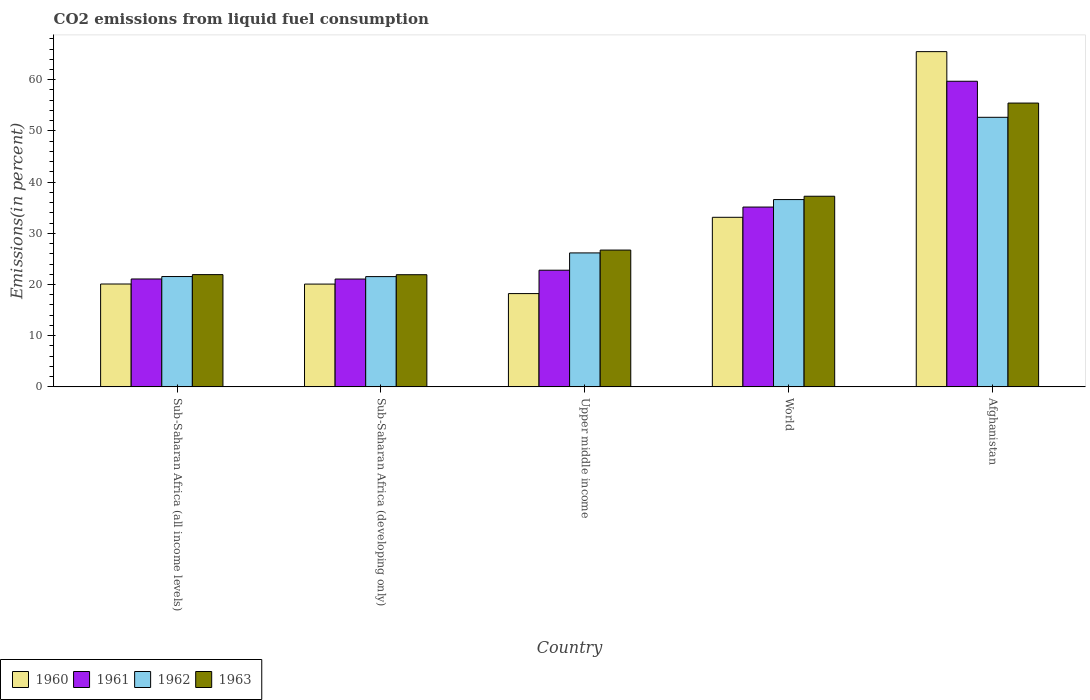How many bars are there on the 1st tick from the left?
Your answer should be very brief. 4. How many bars are there on the 4th tick from the right?
Provide a succinct answer. 4. What is the label of the 1st group of bars from the left?
Provide a succinct answer. Sub-Saharan Africa (all income levels). What is the total CO2 emitted in 1960 in Afghanistan?
Provide a succinct answer. 65.49. Across all countries, what is the maximum total CO2 emitted in 1963?
Your answer should be very brief. 55.44. Across all countries, what is the minimum total CO2 emitted in 1962?
Give a very brief answer. 21.54. In which country was the total CO2 emitted in 1963 maximum?
Your response must be concise. Afghanistan. In which country was the total CO2 emitted in 1961 minimum?
Your answer should be compact. Sub-Saharan Africa (developing only). What is the total total CO2 emitted in 1962 in the graph?
Provide a short and direct response. 158.51. What is the difference between the total CO2 emitted in 1960 in Upper middle income and that in World?
Your answer should be very brief. -14.9. What is the difference between the total CO2 emitted in 1961 in Upper middle income and the total CO2 emitted in 1963 in Afghanistan?
Your answer should be compact. -32.65. What is the average total CO2 emitted in 1961 per country?
Ensure brevity in your answer.  31.95. What is the difference between the total CO2 emitted of/in 1960 and total CO2 emitted of/in 1963 in Sub-Saharan Africa (all income levels)?
Offer a terse response. -1.83. In how many countries, is the total CO2 emitted in 1960 greater than 22 %?
Give a very brief answer. 2. What is the ratio of the total CO2 emitted in 1962 in Sub-Saharan Africa (all income levels) to that in Sub-Saharan Africa (developing only)?
Provide a short and direct response. 1. Is the difference between the total CO2 emitted in 1960 in Sub-Saharan Africa (all income levels) and Upper middle income greater than the difference between the total CO2 emitted in 1963 in Sub-Saharan Africa (all income levels) and Upper middle income?
Provide a short and direct response. Yes. What is the difference between the highest and the second highest total CO2 emitted in 1963?
Your answer should be compact. -10.51. What is the difference between the highest and the lowest total CO2 emitted in 1960?
Offer a very short reply. 47.26. What does the 1st bar from the left in Sub-Saharan Africa (developing only) represents?
Make the answer very short. 1960. Is it the case that in every country, the sum of the total CO2 emitted in 1962 and total CO2 emitted in 1960 is greater than the total CO2 emitted in 1963?
Keep it short and to the point. Yes. Are all the bars in the graph horizontal?
Give a very brief answer. No. How many countries are there in the graph?
Offer a terse response. 5. Are the values on the major ticks of Y-axis written in scientific E-notation?
Ensure brevity in your answer.  No. Does the graph contain any zero values?
Provide a succinct answer. No. How many legend labels are there?
Give a very brief answer. 4. How are the legend labels stacked?
Make the answer very short. Horizontal. What is the title of the graph?
Your answer should be very brief. CO2 emissions from liquid fuel consumption. What is the label or title of the Y-axis?
Make the answer very short. Emissions(in percent). What is the Emissions(in percent) of 1960 in Sub-Saharan Africa (all income levels)?
Keep it short and to the point. 20.09. What is the Emissions(in percent) of 1961 in Sub-Saharan Africa (all income levels)?
Your response must be concise. 21.08. What is the Emissions(in percent) in 1962 in Sub-Saharan Africa (all income levels)?
Provide a short and direct response. 21.55. What is the Emissions(in percent) of 1963 in Sub-Saharan Africa (all income levels)?
Keep it short and to the point. 21.93. What is the Emissions(in percent) in 1960 in Sub-Saharan Africa (developing only)?
Provide a short and direct response. 20.08. What is the Emissions(in percent) of 1961 in Sub-Saharan Africa (developing only)?
Offer a terse response. 21.06. What is the Emissions(in percent) in 1962 in Sub-Saharan Africa (developing only)?
Give a very brief answer. 21.54. What is the Emissions(in percent) of 1963 in Sub-Saharan Africa (developing only)?
Provide a succinct answer. 21.91. What is the Emissions(in percent) of 1960 in Upper middle income?
Keep it short and to the point. 18.22. What is the Emissions(in percent) in 1961 in Upper middle income?
Provide a succinct answer. 22.79. What is the Emissions(in percent) of 1962 in Upper middle income?
Offer a terse response. 26.17. What is the Emissions(in percent) of 1963 in Upper middle income?
Provide a succinct answer. 26.72. What is the Emissions(in percent) in 1960 in World?
Keep it short and to the point. 33.13. What is the Emissions(in percent) of 1961 in World?
Provide a succinct answer. 35.13. What is the Emissions(in percent) of 1962 in World?
Your answer should be compact. 36.59. What is the Emissions(in percent) of 1963 in World?
Your answer should be very brief. 37.24. What is the Emissions(in percent) in 1960 in Afghanistan?
Offer a very short reply. 65.49. What is the Emissions(in percent) of 1961 in Afghanistan?
Your answer should be compact. 59.7. What is the Emissions(in percent) in 1962 in Afghanistan?
Your response must be concise. 52.66. What is the Emissions(in percent) in 1963 in Afghanistan?
Keep it short and to the point. 55.44. Across all countries, what is the maximum Emissions(in percent) in 1960?
Offer a very short reply. 65.49. Across all countries, what is the maximum Emissions(in percent) in 1961?
Give a very brief answer. 59.7. Across all countries, what is the maximum Emissions(in percent) of 1962?
Provide a short and direct response. 52.66. Across all countries, what is the maximum Emissions(in percent) in 1963?
Offer a terse response. 55.44. Across all countries, what is the minimum Emissions(in percent) in 1960?
Provide a succinct answer. 18.22. Across all countries, what is the minimum Emissions(in percent) of 1961?
Your answer should be compact. 21.06. Across all countries, what is the minimum Emissions(in percent) of 1962?
Your answer should be very brief. 21.54. Across all countries, what is the minimum Emissions(in percent) in 1963?
Your answer should be very brief. 21.91. What is the total Emissions(in percent) of 1960 in the graph?
Your response must be concise. 157.01. What is the total Emissions(in percent) in 1961 in the graph?
Make the answer very short. 159.76. What is the total Emissions(in percent) of 1962 in the graph?
Offer a very short reply. 158.51. What is the total Emissions(in percent) in 1963 in the graph?
Your answer should be very brief. 163.24. What is the difference between the Emissions(in percent) of 1960 in Sub-Saharan Africa (all income levels) and that in Sub-Saharan Africa (developing only)?
Your response must be concise. 0.01. What is the difference between the Emissions(in percent) in 1961 in Sub-Saharan Africa (all income levels) and that in Sub-Saharan Africa (developing only)?
Give a very brief answer. 0.01. What is the difference between the Emissions(in percent) in 1962 in Sub-Saharan Africa (all income levels) and that in Sub-Saharan Africa (developing only)?
Offer a terse response. 0.01. What is the difference between the Emissions(in percent) in 1963 in Sub-Saharan Africa (all income levels) and that in Sub-Saharan Africa (developing only)?
Your answer should be compact. 0.02. What is the difference between the Emissions(in percent) in 1960 in Sub-Saharan Africa (all income levels) and that in Upper middle income?
Your response must be concise. 1.87. What is the difference between the Emissions(in percent) in 1961 in Sub-Saharan Africa (all income levels) and that in Upper middle income?
Keep it short and to the point. -1.71. What is the difference between the Emissions(in percent) in 1962 in Sub-Saharan Africa (all income levels) and that in Upper middle income?
Your response must be concise. -4.61. What is the difference between the Emissions(in percent) in 1963 in Sub-Saharan Africa (all income levels) and that in Upper middle income?
Offer a terse response. -4.8. What is the difference between the Emissions(in percent) of 1960 in Sub-Saharan Africa (all income levels) and that in World?
Offer a very short reply. -13.03. What is the difference between the Emissions(in percent) in 1961 in Sub-Saharan Africa (all income levels) and that in World?
Offer a terse response. -14.05. What is the difference between the Emissions(in percent) in 1962 in Sub-Saharan Africa (all income levels) and that in World?
Make the answer very short. -15.03. What is the difference between the Emissions(in percent) in 1963 in Sub-Saharan Africa (all income levels) and that in World?
Keep it short and to the point. -15.31. What is the difference between the Emissions(in percent) in 1960 in Sub-Saharan Africa (all income levels) and that in Afghanistan?
Your response must be concise. -45.39. What is the difference between the Emissions(in percent) of 1961 in Sub-Saharan Africa (all income levels) and that in Afghanistan?
Your answer should be very brief. -38.62. What is the difference between the Emissions(in percent) in 1962 in Sub-Saharan Africa (all income levels) and that in Afghanistan?
Provide a short and direct response. -31.11. What is the difference between the Emissions(in percent) in 1963 in Sub-Saharan Africa (all income levels) and that in Afghanistan?
Your answer should be very brief. -33.51. What is the difference between the Emissions(in percent) in 1960 in Sub-Saharan Africa (developing only) and that in Upper middle income?
Keep it short and to the point. 1.86. What is the difference between the Emissions(in percent) of 1961 in Sub-Saharan Africa (developing only) and that in Upper middle income?
Ensure brevity in your answer.  -1.73. What is the difference between the Emissions(in percent) of 1962 in Sub-Saharan Africa (developing only) and that in Upper middle income?
Offer a very short reply. -4.63. What is the difference between the Emissions(in percent) in 1963 in Sub-Saharan Africa (developing only) and that in Upper middle income?
Ensure brevity in your answer.  -4.82. What is the difference between the Emissions(in percent) of 1960 in Sub-Saharan Africa (developing only) and that in World?
Keep it short and to the point. -13.05. What is the difference between the Emissions(in percent) in 1961 in Sub-Saharan Africa (developing only) and that in World?
Your response must be concise. -14.06. What is the difference between the Emissions(in percent) in 1962 in Sub-Saharan Africa (developing only) and that in World?
Your answer should be compact. -15.05. What is the difference between the Emissions(in percent) of 1963 in Sub-Saharan Africa (developing only) and that in World?
Provide a short and direct response. -15.33. What is the difference between the Emissions(in percent) of 1960 in Sub-Saharan Africa (developing only) and that in Afghanistan?
Offer a terse response. -45.41. What is the difference between the Emissions(in percent) of 1961 in Sub-Saharan Africa (developing only) and that in Afghanistan?
Keep it short and to the point. -38.64. What is the difference between the Emissions(in percent) in 1962 in Sub-Saharan Africa (developing only) and that in Afghanistan?
Your answer should be compact. -31.12. What is the difference between the Emissions(in percent) of 1963 in Sub-Saharan Africa (developing only) and that in Afghanistan?
Provide a short and direct response. -33.53. What is the difference between the Emissions(in percent) of 1960 in Upper middle income and that in World?
Make the answer very short. -14.9. What is the difference between the Emissions(in percent) of 1961 in Upper middle income and that in World?
Your answer should be very brief. -12.34. What is the difference between the Emissions(in percent) in 1962 in Upper middle income and that in World?
Your answer should be very brief. -10.42. What is the difference between the Emissions(in percent) of 1963 in Upper middle income and that in World?
Give a very brief answer. -10.51. What is the difference between the Emissions(in percent) in 1960 in Upper middle income and that in Afghanistan?
Offer a very short reply. -47.26. What is the difference between the Emissions(in percent) in 1961 in Upper middle income and that in Afghanistan?
Keep it short and to the point. -36.91. What is the difference between the Emissions(in percent) of 1962 in Upper middle income and that in Afghanistan?
Your answer should be very brief. -26.49. What is the difference between the Emissions(in percent) of 1963 in Upper middle income and that in Afghanistan?
Provide a succinct answer. -28.72. What is the difference between the Emissions(in percent) in 1960 in World and that in Afghanistan?
Offer a terse response. -32.36. What is the difference between the Emissions(in percent) of 1961 in World and that in Afghanistan?
Your response must be concise. -24.57. What is the difference between the Emissions(in percent) in 1962 in World and that in Afghanistan?
Ensure brevity in your answer.  -16.07. What is the difference between the Emissions(in percent) of 1963 in World and that in Afghanistan?
Your answer should be compact. -18.2. What is the difference between the Emissions(in percent) in 1960 in Sub-Saharan Africa (all income levels) and the Emissions(in percent) in 1961 in Sub-Saharan Africa (developing only)?
Keep it short and to the point. -0.97. What is the difference between the Emissions(in percent) of 1960 in Sub-Saharan Africa (all income levels) and the Emissions(in percent) of 1962 in Sub-Saharan Africa (developing only)?
Keep it short and to the point. -1.45. What is the difference between the Emissions(in percent) in 1960 in Sub-Saharan Africa (all income levels) and the Emissions(in percent) in 1963 in Sub-Saharan Africa (developing only)?
Keep it short and to the point. -1.81. What is the difference between the Emissions(in percent) in 1961 in Sub-Saharan Africa (all income levels) and the Emissions(in percent) in 1962 in Sub-Saharan Africa (developing only)?
Give a very brief answer. -0.46. What is the difference between the Emissions(in percent) in 1961 in Sub-Saharan Africa (all income levels) and the Emissions(in percent) in 1963 in Sub-Saharan Africa (developing only)?
Keep it short and to the point. -0.83. What is the difference between the Emissions(in percent) of 1962 in Sub-Saharan Africa (all income levels) and the Emissions(in percent) of 1963 in Sub-Saharan Africa (developing only)?
Your answer should be compact. -0.35. What is the difference between the Emissions(in percent) in 1960 in Sub-Saharan Africa (all income levels) and the Emissions(in percent) in 1961 in Upper middle income?
Your answer should be very brief. -2.69. What is the difference between the Emissions(in percent) of 1960 in Sub-Saharan Africa (all income levels) and the Emissions(in percent) of 1962 in Upper middle income?
Provide a succinct answer. -6.07. What is the difference between the Emissions(in percent) in 1960 in Sub-Saharan Africa (all income levels) and the Emissions(in percent) in 1963 in Upper middle income?
Give a very brief answer. -6.63. What is the difference between the Emissions(in percent) of 1961 in Sub-Saharan Africa (all income levels) and the Emissions(in percent) of 1962 in Upper middle income?
Offer a very short reply. -5.09. What is the difference between the Emissions(in percent) of 1961 in Sub-Saharan Africa (all income levels) and the Emissions(in percent) of 1963 in Upper middle income?
Offer a very short reply. -5.65. What is the difference between the Emissions(in percent) of 1962 in Sub-Saharan Africa (all income levels) and the Emissions(in percent) of 1963 in Upper middle income?
Ensure brevity in your answer.  -5.17. What is the difference between the Emissions(in percent) in 1960 in Sub-Saharan Africa (all income levels) and the Emissions(in percent) in 1961 in World?
Provide a short and direct response. -15.03. What is the difference between the Emissions(in percent) in 1960 in Sub-Saharan Africa (all income levels) and the Emissions(in percent) in 1962 in World?
Offer a terse response. -16.49. What is the difference between the Emissions(in percent) of 1960 in Sub-Saharan Africa (all income levels) and the Emissions(in percent) of 1963 in World?
Your answer should be compact. -17.14. What is the difference between the Emissions(in percent) of 1961 in Sub-Saharan Africa (all income levels) and the Emissions(in percent) of 1962 in World?
Keep it short and to the point. -15.51. What is the difference between the Emissions(in percent) of 1961 in Sub-Saharan Africa (all income levels) and the Emissions(in percent) of 1963 in World?
Give a very brief answer. -16.16. What is the difference between the Emissions(in percent) of 1962 in Sub-Saharan Africa (all income levels) and the Emissions(in percent) of 1963 in World?
Your answer should be very brief. -15.69. What is the difference between the Emissions(in percent) of 1960 in Sub-Saharan Africa (all income levels) and the Emissions(in percent) of 1961 in Afghanistan?
Provide a succinct answer. -39.61. What is the difference between the Emissions(in percent) of 1960 in Sub-Saharan Africa (all income levels) and the Emissions(in percent) of 1962 in Afghanistan?
Provide a short and direct response. -32.56. What is the difference between the Emissions(in percent) in 1960 in Sub-Saharan Africa (all income levels) and the Emissions(in percent) in 1963 in Afghanistan?
Offer a very short reply. -35.35. What is the difference between the Emissions(in percent) of 1961 in Sub-Saharan Africa (all income levels) and the Emissions(in percent) of 1962 in Afghanistan?
Keep it short and to the point. -31.58. What is the difference between the Emissions(in percent) of 1961 in Sub-Saharan Africa (all income levels) and the Emissions(in percent) of 1963 in Afghanistan?
Offer a very short reply. -34.36. What is the difference between the Emissions(in percent) in 1962 in Sub-Saharan Africa (all income levels) and the Emissions(in percent) in 1963 in Afghanistan?
Offer a very short reply. -33.89. What is the difference between the Emissions(in percent) of 1960 in Sub-Saharan Africa (developing only) and the Emissions(in percent) of 1961 in Upper middle income?
Offer a very short reply. -2.71. What is the difference between the Emissions(in percent) of 1960 in Sub-Saharan Africa (developing only) and the Emissions(in percent) of 1962 in Upper middle income?
Ensure brevity in your answer.  -6.09. What is the difference between the Emissions(in percent) in 1960 in Sub-Saharan Africa (developing only) and the Emissions(in percent) in 1963 in Upper middle income?
Offer a very short reply. -6.65. What is the difference between the Emissions(in percent) of 1961 in Sub-Saharan Africa (developing only) and the Emissions(in percent) of 1962 in Upper middle income?
Keep it short and to the point. -5.1. What is the difference between the Emissions(in percent) in 1961 in Sub-Saharan Africa (developing only) and the Emissions(in percent) in 1963 in Upper middle income?
Give a very brief answer. -5.66. What is the difference between the Emissions(in percent) of 1962 in Sub-Saharan Africa (developing only) and the Emissions(in percent) of 1963 in Upper middle income?
Provide a succinct answer. -5.18. What is the difference between the Emissions(in percent) in 1960 in Sub-Saharan Africa (developing only) and the Emissions(in percent) in 1961 in World?
Your answer should be very brief. -15.05. What is the difference between the Emissions(in percent) of 1960 in Sub-Saharan Africa (developing only) and the Emissions(in percent) of 1962 in World?
Your answer should be very brief. -16.51. What is the difference between the Emissions(in percent) of 1960 in Sub-Saharan Africa (developing only) and the Emissions(in percent) of 1963 in World?
Ensure brevity in your answer.  -17.16. What is the difference between the Emissions(in percent) of 1961 in Sub-Saharan Africa (developing only) and the Emissions(in percent) of 1962 in World?
Make the answer very short. -15.52. What is the difference between the Emissions(in percent) in 1961 in Sub-Saharan Africa (developing only) and the Emissions(in percent) in 1963 in World?
Keep it short and to the point. -16.18. What is the difference between the Emissions(in percent) of 1962 in Sub-Saharan Africa (developing only) and the Emissions(in percent) of 1963 in World?
Offer a very short reply. -15.7. What is the difference between the Emissions(in percent) of 1960 in Sub-Saharan Africa (developing only) and the Emissions(in percent) of 1961 in Afghanistan?
Provide a short and direct response. -39.62. What is the difference between the Emissions(in percent) in 1960 in Sub-Saharan Africa (developing only) and the Emissions(in percent) in 1962 in Afghanistan?
Ensure brevity in your answer.  -32.58. What is the difference between the Emissions(in percent) in 1960 in Sub-Saharan Africa (developing only) and the Emissions(in percent) in 1963 in Afghanistan?
Ensure brevity in your answer.  -35.36. What is the difference between the Emissions(in percent) of 1961 in Sub-Saharan Africa (developing only) and the Emissions(in percent) of 1962 in Afghanistan?
Your answer should be compact. -31.6. What is the difference between the Emissions(in percent) of 1961 in Sub-Saharan Africa (developing only) and the Emissions(in percent) of 1963 in Afghanistan?
Provide a short and direct response. -34.38. What is the difference between the Emissions(in percent) in 1962 in Sub-Saharan Africa (developing only) and the Emissions(in percent) in 1963 in Afghanistan?
Offer a terse response. -33.9. What is the difference between the Emissions(in percent) in 1960 in Upper middle income and the Emissions(in percent) in 1961 in World?
Your answer should be compact. -16.9. What is the difference between the Emissions(in percent) of 1960 in Upper middle income and the Emissions(in percent) of 1962 in World?
Your response must be concise. -18.36. What is the difference between the Emissions(in percent) of 1960 in Upper middle income and the Emissions(in percent) of 1963 in World?
Your answer should be compact. -19.02. What is the difference between the Emissions(in percent) of 1961 in Upper middle income and the Emissions(in percent) of 1962 in World?
Your answer should be very brief. -13.8. What is the difference between the Emissions(in percent) in 1961 in Upper middle income and the Emissions(in percent) in 1963 in World?
Your answer should be very brief. -14.45. What is the difference between the Emissions(in percent) in 1962 in Upper middle income and the Emissions(in percent) in 1963 in World?
Provide a short and direct response. -11.07. What is the difference between the Emissions(in percent) in 1960 in Upper middle income and the Emissions(in percent) in 1961 in Afghanistan?
Offer a terse response. -41.48. What is the difference between the Emissions(in percent) in 1960 in Upper middle income and the Emissions(in percent) in 1962 in Afghanistan?
Your answer should be compact. -34.44. What is the difference between the Emissions(in percent) in 1960 in Upper middle income and the Emissions(in percent) in 1963 in Afghanistan?
Ensure brevity in your answer.  -37.22. What is the difference between the Emissions(in percent) of 1961 in Upper middle income and the Emissions(in percent) of 1962 in Afghanistan?
Make the answer very short. -29.87. What is the difference between the Emissions(in percent) of 1961 in Upper middle income and the Emissions(in percent) of 1963 in Afghanistan?
Keep it short and to the point. -32.65. What is the difference between the Emissions(in percent) in 1962 in Upper middle income and the Emissions(in percent) in 1963 in Afghanistan?
Provide a succinct answer. -29.27. What is the difference between the Emissions(in percent) in 1960 in World and the Emissions(in percent) in 1961 in Afghanistan?
Offer a very short reply. -26.58. What is the difference between the Emissions(in percent) in 1960 in World and the Emissions(in percent) in 1962 in Afghanistan?
Your response must be concise. -19.53. What is the difference between the Emissions(in percent) of 1960 in World and the Emissions(in percent) of 1963 in Afghanistan?
Keep it short and to the point. -22.32. What is the difference between the Emissions(in percent) in 1961 in World and the Emissions(in percent) in 1962 in Afghanistan?
Offer a very short reply. -17.53. What is the difference between the Emissions(in percent) of 1961 in World and the Emissions(in percent) of 1963 in Afghanistan?
Provide a short and direct response. -20.31. What is the difference between the Emissions(in percent) of 1962 in World and the Emissions(in percent) of 1963 in Afghanistan?
Provide a short and direct response. -18.85. What is the average Emissions(in percent) in 1960 per country?
Your response must be concise. 31.4. What is the average Emissions(in percent) of 1961 per country?
Make the answer very short. 31.95. What is the average Emissions(in percent) of 1962 per country?
Keep it short and to the point. 31.7. What is the average Emissions(in percent) of 1963 per country?
Keep it short and to the point. 32.65. What is the difference between the Emissions(in percent) of 1960 and Emissions(in percent) of 1961 in Sub-Saharan Africa (all income levels)?
Your answer should be compact. -0.98. What is the difference between the Emissions(in percent) in 1960 and Emissions(in percent) in 1962 in Sub-Saharan Africa (all income levels)?
Offer a terse response. -1.46. What is the difference between the Emissions(in percent) of 1960 and Emissions(in percent) of 1963 in Sub-Saharan Africa (all income levels)?
Your answer should be very brief. -1.83. What is the difference between the Emissions(in percent) in 1961 and Emissions(in percent) in 1962 in Sub-Saharan Africa (all income levels)?
Provide a short and direct response. -0.48. What is the difference between the Emissions(in percent) of 1961 and Emissions(in percent) of 1963 in Sub-Saharan Africa (all income levels)?
Ensure brevity in your answer.  -0.85. What is the difference between the Emissions(in percent) of 1962 and Emissions(in percent) of 1963 in Sub-Saharan Africa (all income levels)?
Offer a very short reply. -0.37. What is the difference between the Emissions(in percent) in 1960 and Emissions(in percent) in 1961 in Sub-Saharan Africa (developing only)?
Your response must be concise. -0.98. What is the difference between the Emissions(in percent) of 1960 and Emissions(in percent) of 1962 in Sub-Saharan Africa (developing only)?
Ensure brevity in your answer.  -1.46. What is the difference between the Emissions(in percent) in 1960 and Emissions(in percent) in 1963 in Sub-Saharan Africa (developing only)?
Offer a very short reply. -1.83. What is the difference between the Emissions(in percent) of 1961 and Emissions(in percent) of 1962 in Sub-Saharan Africa (developing only)?
Offer a terse response. -0.48. What is the difference between the Emissions(in percent) of 1961 and Emissions(in percent) of 1963 in Sub-Saharan Africa (developing only)?
Make the answer very short. -0.85. What is the difference between the Emissions(in percent) in 1962 and Emissions(in percent) in 1963 in Sub-Saharan Africa (developing only)?
Your answer should be compact. -0.37. What is the difference between the Emissions(in percent) in 1960 and Emissions(in percent) in 1961 in Upper middle income?
Provide a succinct answer. -4.57. What is the difference between the Emissions(in percent) of 1960 and Emissions(in percent) of 1962 in Upper middle income?
Your response must be concise. -7.94. What is the difference between the Emissions(in percent) of 1960 and Emissions(in percent) of 1963 in Upper middle income?
Ensure brevity in your answer.  -8.5. What is the difference between the Emissions(in percent) in 1961 and Emissions(in percent) in 1962 in Upper middle income?
Your answer should be very brief. -3.38. What is the difference between the Emissions(in percent) of 1961 and Emissions(in percent) of 1963 in Upper middle income?
Provide a succinct answer. -3.94. What is the difference between the Emissions(in percent) of 1962 and Emissions(in percent) of 1963 in Upper middle income?
Ensure brevity in your answer.  -0.56. What is the difference between the Emissions(in percent) of 1960 and Emissions(in percent) of 1961 in World?
Offer a very short reply. -2. What is the difference between the Emissions(in percent) in 1960 and Emissions(in percent) in 1962 in World?
Keep it short and to the point. -3.46. What is the difference between the Emissions(in percent) in 1960 and Emissions(in percent) in 1963 in World?
Offer a terse response. -4.11. What is the difference between the Emissions(in percent) of 1961 and Emissions(in percent) of 1962 in World?
Offer a terse response. -1.46. What is the difference between the Emissions(in percent) in 1961 and Emissions(in percent) in 1963 in World?
Give a very brief answer. -2.11. What is the difference between the Emissions(in percent) of 1962 and Emissions(in percent) of 1963 in World?
Make the answer very short. -0.65. What is the difference between the Emissions(in percent) in 1960 and Emissions(in percent) in 1961 in Afghanistan?
Provide a short and direct response. 5.79. What is the difference between the Emissions(in percent) in 1960 and Emissions(in percent) in 1962 in Afghanistan?
Offer a terse response. 12.83. What is the difference between the Emissions(in percent) in 1960 and Emissions(in percent) in 1963 in Afghanistan?
Your response must be concise. 10.05. What is the difference between the Emissions(in percent) in 1961 and Emissions(in percent) in 1962 in Afghanistan?
Your response must be concise. 7.04. What is the difference between the Emissions(in percent) in 1961 and Emissions(in percent) in 1963 in Afghanistan?
Your answer should be very brief. 4.26. What is the difference between the Emissions(in percent) in 1962 and Emissions(in percent) in 1963 in Afghanistan?
Ensure brevity in your answer.  -2.78. What is the ratio of the Emissions(in percent) of 1960 in Sub-Saharan Africa (all income levels) to that in Sub-Saharan Africa (developing only)?
Provide a succinct answer. 1. What is the ratio of the Emissions(in percent) of 1961 in Sub-Saharan Africa (all income levels) to that in Sub-Saharan Africa (developing only)?
Your answer should be compact. 1. What is the ratio of the Emissions(in percent) in 1962 in Sub-Saharan Africa (all income levels) to that in Sub-Saharan Africa (developing only)?
Your answer should be very brief. 1. What is the ratio of the Emissions(in percent) in 1960 in Sub-Saharan Africa (all income levels) to that in Upper middle income?
Offer a terse response. 1.1. What is the ratio of the Emissions(in percent) of 1961 in Sub-Saharan Africa (all income levels) to that in Upper middle income?
Your answer should be compact. 0.92. What is the ratio of the Emissions(in percent) in 1962 in Sub-Saharan Africa (all income levels) to that in Upper middle income?
Make the answer very short. 0.82. What is the ratio of the Emissions(in percent) of 1963 in Sub-Saharan Africa (all income levels) to that in Upper middle income?
Make the answer very short. 0.82. What is the ratio of the Emissions(in percent) of 1960 in Sub-Saharan Africa (all income levels) to that in World?
Your response must be concise. 0.61. What is the ratio of the Emissions(in percent) in 1961 in Sub-Saharan Africa (all income levels) to that in World?
Offer a terse response. 0.6. What is the ratio of the Emissions(in percent) of 1962 in Sub-Saharan Africa (all income levels) to that in World?
Offer a very short reply. 0.59. What is the ratio of the Emissions(in percent) of 1963 in Sub-Saharan Africa (all income levels) to that in World?
Offer a very short reply. 0.59. What is the ratio of the Emissions(in percent) in 1960 in Sub-Saharan Africa (all income levels) to that in Afghanistan?
Provide a short and direct response. 0.31. What is the ratio of the Emissions(in percent) of 1961 in Sub-Saharan Africa (all income levels) to that in Afghanistan?
Provide a succinct answer. 0.35. What is the ratio of the Emissions(in percent) in 1962 in Sub-Saharan Africa (all income levels) to that in Afghanistan?
Provide a succinct answer. 0.41. What is the ratio of the Emissions(in percent) of 1963 in Sub-Saharan Africa (all income levels) to that in Afghanistan?
Ensure brevity in your answer.  0.4. What is the ratio of the Emissions(in percent) of 1960 in Sub-Saharan Africa (developing only) to that in Upper middle income?
Offer a terse response. 1.1. What is the ratio of the Emissions(in percent) of 1961 in Sub-Saharan Africa (developing only) to that in Upper middle income?
Ensure brevity in your answer.  0.92. What is the ratio of the Emissions(in percent) in 1962 in Sub-Saharan Africa (developing only) to that in Upper middle income?
Ensure brevity in your answer.  0.82. What is the ratio of the Emissions(in percent) in 1963 in Sub-Saharan Africa (developing only) to that in Upper middle income?
Offer a terse response. 0.82. What is the ratio of the Emissions(in percent) of 1960 in Sub-Saharan Africa (developing only) to that in World?
Your answer should be very brief. 0.61. What is the ratio of the Emissions(in percent) in 1961 in Sub-Saharan Africa (developing only) to that in World?
Keep it short and to the point. 0.6. What is the ratio of the Emissions(in percent) in 1962 in Sub-Saharan Africa (developing only) to that in World?
Keep it short and to the point. 0.59. What is the ratio of the Emissions(in percent) of 1963 in Sub-Saharan Africa (developing only) to that in World?
Keep it short and to the point. 0.59. What is the ratio of the Emissions(in percent) of 1960 in Sub-Saharan Africa (developing only) to that in Afghanistan?
Your answer should be compact. 0.31. What is the ratio of the Emissions(in percent) in 1961 in Sub-Saharan Africa (developing only) to that in Afghanistan?
Offer a very short reply. 0.35. What is the ratio of the Emissions(in percent) in 1962 in Sub-Saharan Africa (developing only) to that in Afghanistan?
Provide a short and direct response. 0.41. What is the ratio of the Emissions(in percent) of 1963 in Sub-Saharan Africa (developing only) to that in Afghanistan?
Your answer should be compact. 0.4. What is the ratio of the Emissions(in percent) in 1960 in Upper middle income to that in World?
Ensure brevity in your answer.  0.55. What is the ratio of the Emissions(in percent) in 1961 in Upper middle income to that in World?
Your response must be concise. 0.65. What is the ratio of the Emissions(in percent) in 1962 in Upper middle income to that in World?
Offer a terse response. 0.72. What is the ratio of the Emissions(in percent) of 1963 in Upper middle income to that in World?
Your answer should be compact. 0.72. What is the ratio of the Emissions(in percent) of 1960 in Upper middle income to that in Afghanistan?
Offer a very short reply. 0.28. What is the ratio of the Emissions(in percent) of 1961 in Upper middle income to that in Afghanistan?
Your answer should be very brief. 0.38. What is the ratio of the Emissions(in percent) of 1962 in Upper middle income to that in Afghanistan?
Your answer should be very brief. 0.5. What is the ratio of the Emissions(in percent) in 1963 in Upper middle income to that in Afghanistan?
Make the answer very short. 0.48. What is the ratio of the Emissions(in percent) of 1960 in World to that in Afghanistan?
Your response must be concise. 0.51. What is the ratio of the Emissions(in percent) in 1961 in World to that in Afghanistan?
Ensure brevity in your answer.  0.59. What is the ratio of the Emissions(in percent) in 1962 in World to that in Afghanistan?
Offer a very short reply. 0.69. What is the ratio of the Emissions(in percent) of 1963 in World to that in Afghanistan?
Offer a very short reply. 0.67. What is the difference between the highest and the second highest Emissions(in percent) of 1960?
Offer a very short reply. 32.36. What is the difference between the highest and the second highest Emissions(in percent) in 1961?
Provide a succinct answer. 24.57. What is the difference between the highest and the second highest Emissions(in percent) of 1962?
Offer a very short reply. 16.07. What is the difference between the highest and the second highest Emissions(in percent) of 1963?
Provide a short and direct response. 18.2. What is the difference between the highest and the lowest Emissions(in percent) of 1960?
Your answer should be very brief. 47.26. What is the difference between the highest and the lowest Emissions(in percent) of 1961?
Offer a terse response. 38.64. What is the difference between the highest and the lowest Emissions(in percent) of 1962?
Your answer should be very brief. 31.12. What is the difference between the highest and the lowest Emissions(in percent) of 1963?
Make the answer very short. 33.53. 